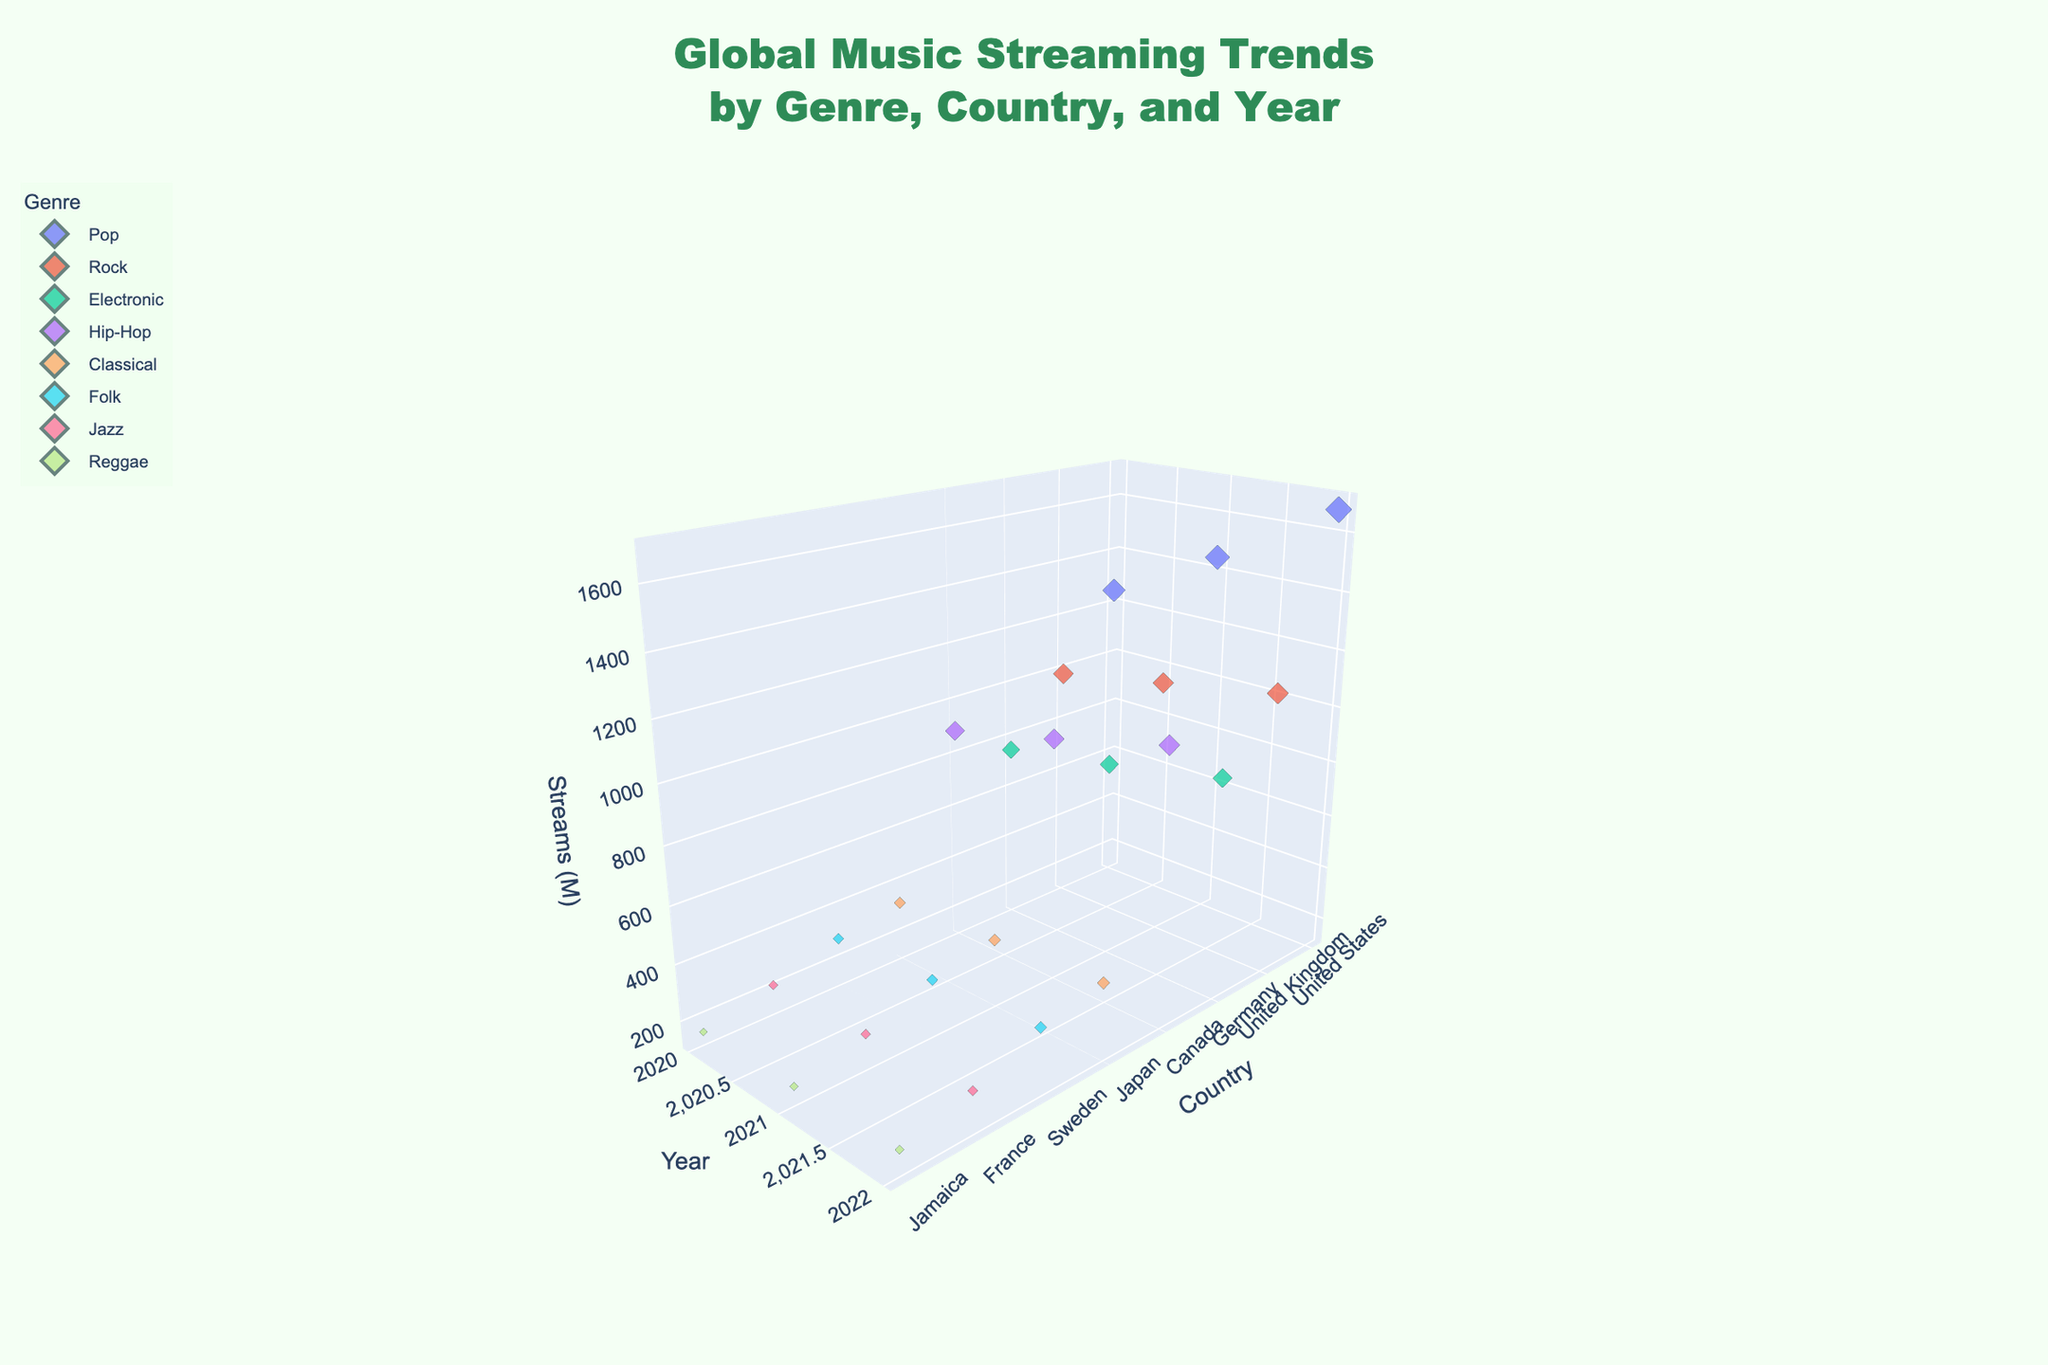What is the title of the plot? The title is located at the top center of the figure and is designed to describe the plot's content. In this case, it states "Global Music Streaming Trends by Genre, Country, and Year."
Answer: Global Music Streaming Trends by Genre, Country, and Year Which genre has the largest increase in streams from 2020 to 2022? To determine this, identify the genres, then compare the stream counts in 2020 and 2022 for each genre, and calculate the increase. Pop shows the largest increase from 1250 million streams in 2020 to 1680 million streams in 2022.
Answer: Pop Which country had the highest number of streams in 2021? Locate the data points for 2021. The highest point on the z-axis (streams) in 2021 is from the United States.
Answer: United States How do the stream counts for Hip-Hop in Canada trend from 2020 to 2022? Examine the data points for Hip-Hop in Canada over the years 2020, 2021, and 2022. The stream counts are 890 million in 2020, 980 million in 2021, and 1080 million in 2022, showing a steady increase.
Answer: Steady increase What is the average number of streams for Classical music in Japan from 2020 to 2022? Find the stream counts for Classical music in Japan across the years 2020, 2021, and 2022, sum them up, and divide by the number of years. The counts are 320, 350, and 380 million respectively. The average is (320 + 350 + 380) / 3 = 350 million.
Answer: 350 million Which genre had the lowest number of streams in 2020, and how many streams were there? Identify the lowest point on the z-axis for the year 2020 and find the corresponding genre. Jazz in France had the lowest streams with 210 million.
Answer: Jazz, 210 million Compare the streams of Pop in the United States in 2020 with Rock in the United Kingdom in 2022. Which one is higher and by how much? Locate the data points: Pop in 2020 had 1250 million streams, and Rock in 2022 had 1120 million streams. Subtract the smaller value from the larger one: 1250 - 1120 = 130 million. Pop in 2020 is higher by 130 million streams.
Answer: Pop by 130 million What proportion of the total streams in 2022 does Jazz in France represent? Sum all stream counts for 2022, then divide Jazz's streams by this total and multiply by 100 for the percentage. The streams are: Pop 1680, Rock 1120, Electronic 900, Hip-Hop 1080, Classical 380, Folk 340, Jazz 250, Reggae 190. Total is 5940 million. Jazz is 250 million. Proportion is (250 / 5940) * 100 ≈ 4.21%.
Answer: Approximately 4.21% What pattern do you observe for the Reggae genre's stream counts from 2020 to 2022? Examine the stream counts for Reggae in Jamaica over the years, with values 150 million in 2020, 170 million in 2021, and 190 million in 2022, indicating a gradual increase.
Answer: Gradual increase 